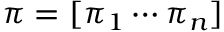Convert formula to latex. <formula><loc_0><loc_0><loc_500><loc_500>\pi = [ \pi _ { 1 } \cdots \pi _ { n } ]</formula> 